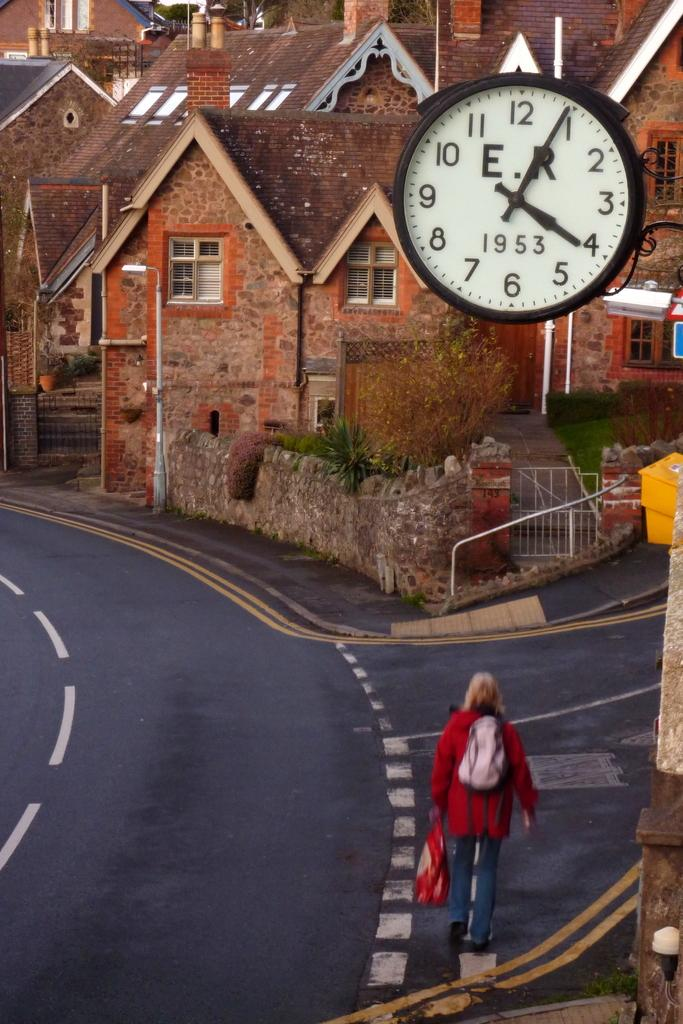What type of structures can be seen in the image? There are houses in the image. What is the woman on the road doing? The woman is standing on the road and holding luggage. What object in the image might be used for telling time? There is a clock in the image. What other object can be seen in the image besides the houses and the woman? There is a pole in the image. What is the name of the woman in the image? The provided facts do not mention the name of the woman, so we cannot determine her name from the image. What type of interest does the pole in the image represent? The provided facts do not mention any specific interest or purpose for the pole, so we cannot determine its significance from the image. 